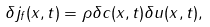<formula> <loc_0><loc_0><loc_500><loc_500>\delta j _ { f } ( x , t ) = \rho \delta c ( x , t ) \delta u ( x , t ) ,</formula> 